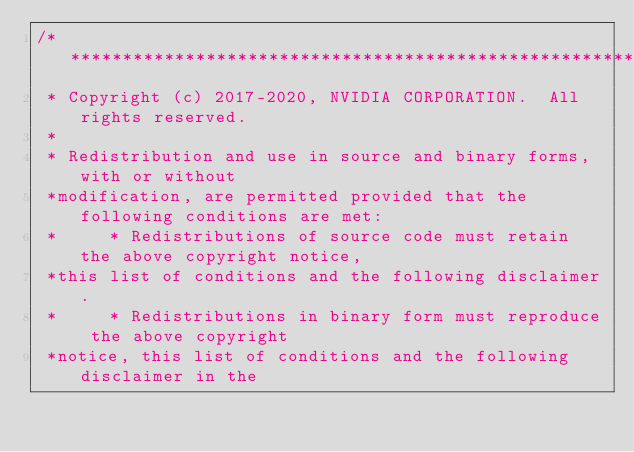<code> <loc_0><loc_0><loc_500><loc_500><_Cuda_>/***************************************************************************************************
 * Copyright (c) 2017-2020, NVIDIA CORPORATION.  All rights reserved.
 *
 * Redistribution and use in source and binary forms, with or without
 *modification, are permitted provided that the following conditions are met:
 *     * Redistributions of source code must retain the above copyright notice,
 *this list of conditions and the following disclaimer.
 *     * Redistributions in binary form must reproduce the above copyright
 *notice, this list of conditions and the following disclaimer in the</code> 